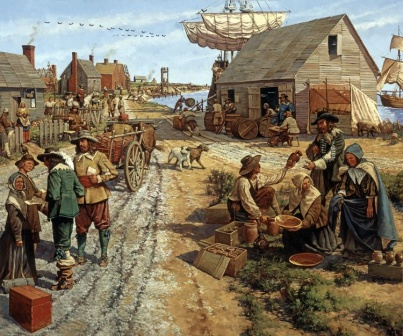Imagine you are one of the villagers in this scene. Describe your daily routine. As a villager in this colonial-era scene, my daily routine would include a mix of essential tasks and social interactions. I would start my day early, tending to my small garden or farm to ensure we have enough fresh produce. After a hearty breakfast, I would head to the marketplace, either to sell my goods or to purchase necessary items. The marketplace is a hub of activity, where I can catch up with neighbors and hear the latest news. By midday, I might assist in loading or unloading goods from the carts or the ship at the harbor, contributing to the village's trade activities. In the afternoon, I could help mend tools or prepare meals. The evenings would be spent with family, perhaps by the fire, before retiring early to rest for another busy day in our vibrant coastal village. 